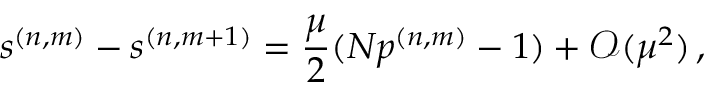Convert formula to latex. <formula><loc_0><loc_0><loc_500><loc_500>s ^ { ( n , m ) } - s ^ { ( n , m + 1 ) } = \frac { \mu } { 2 } ( N p ^ { ( n , m ) } - 1 ) + \mathcal { O } ( \mu ^ { 2 } ) \, ,</formula> 